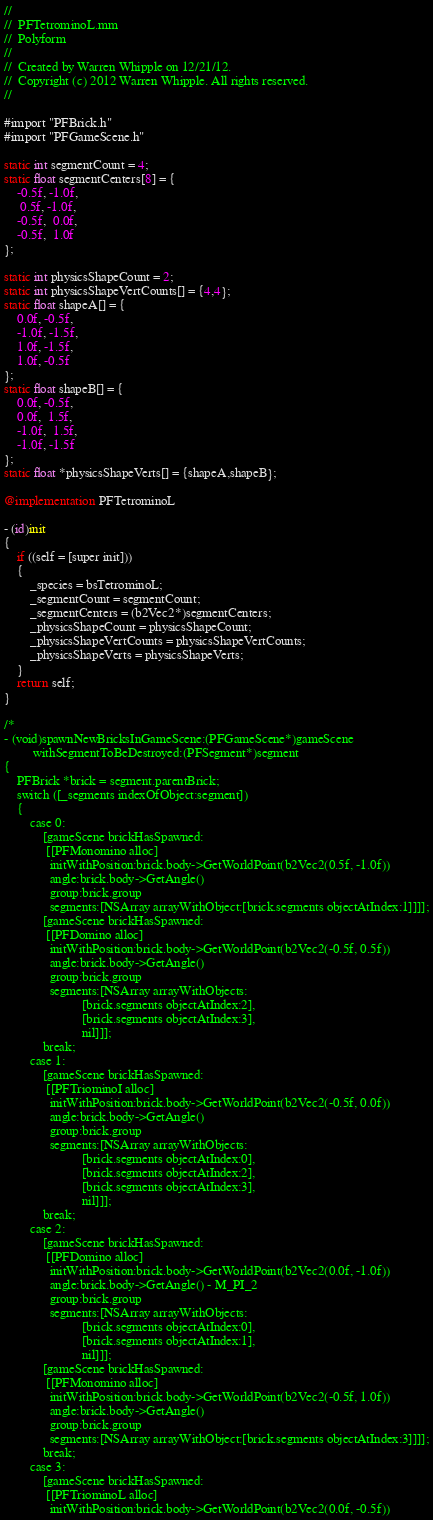<code> <loc_0><loc_0><loc_500><loc_500><_ObjectiveC_>//
//  PFTetrominoL.mm
//  Polyform
//
//  Created by Warren Whipple on 12/21/12.
//  Copyright (c) 2012 Warren Whipple. All rights reserved.
//

#import "PFBrick.h"
#import "PFGameScene.h"

static int segmentCount = 4;
static float segmentCenters[8] = {
    -0.5f, -1.0f,
     0.5f, -1.0f,
    -0.5f,  0.0f,
    -0.5f,  1.0f
};

static int physicsShapeCount = 2;
static int physicsShapeVertCounts[] = {4,4};
static float shapeA[] = {
    0.0f, -0.5f,
    -1.0f, -1.5f,
    1.0f, -1.5f,
    1.0f, -0.5f
};
static float shapeB[] = {
    0.0f, -0.5f,
    0.0f,  1.5f,
    -1.0f,  1.5f,
    -1.0f, -1.5f
};
static float *physicsShapeVerts[] = {shapeA,shapeB};

@implementation PFTetrominoL

- (id)init
{
    if ((self = [super init]))
    {
        _species = bsTetrominoL;
        _segmentCount = segmentCount;
        _segmentCenters = (b2Vec2*)segmentCenters;
        _physicsShapeCount = physicsShapeCount;
        _physicsShapeVertCounts = physicsShapeVertCounts;
        _physicsShapeVerts = physicsShapeVerts;
    }
    return self;
}

/*
- (void)spawnNewBricksInGameScene:(PFGameScene*)gameScene
         withSegmentToBeDestroyed:(PFSegment*)segment
{
    PFBrick *brick = segment.parentBrick;
    switch ([_segments indexOfObject:segment])
    {
        case 0:
            [gameScene brickHasSpawned:
             [[PFMonomino alloc]
              initWithPosition:brick.body->GetWorldPoint(b2Vec2(0.5f, -1.0f))
              angle:brick.body->GetAngle()
              group:brick.group
              segments:[NSArray arrayWithObject:[brick.segments objectAtIndex:1]]]];
            [gameScene brickHasSpawned:
             [[PFDomino alloc]
              initWithPosition:brick.body->GetWorldPoint(b2Vec2(-0.5f, 0.5f))
              angle:brick.body->GetAngle()
              group:brick.group
              segments:[NSArray arrayWithObjects:
                        [brick.segments objectAtIndex:2],
                        [brick.segments objectAtIndex:3],
                        nil]]];
            break;
        case 1:
            [gameScene brickHasSpawned:
             [[PFTriominoI alloc]
              initWithPosition:brick.body->GetWorldPoint(b2Vec2(-0.5f, 0.0f))
              angle:brick.body->GetAngle()
              group:brick.group
              segments:[NSArray arrayWithObjects:
                        [brick.segments objectAtIndex:0],
                        [brick.segments objectAtIndex:2],
                        [brick.segments objectAtIndex:3],
                        nil]]];
            break;
        case 2:
            [gameScene brickHasSpawned:
             [[PFDomino alloc]
              initWithPosition:brick.body->GetWorldPoint(b2Vec2(0.0f, -1.0f))
              angle:brick.body->GetAngle() - M_PI_2
              group:brick.group
              segments:[NSArray arrayWithObjects:
                        [brick.segments objectAtIndex:0],
                        [brick.segments objectAtIndex:1],
                        nil]]];
            [gameScene brickHasSpawned:
             [[PFMonomino alloc]
              initWithPosition:brick.body->GetWorldPoint(b2Vec2(-0.5f, 1.0f))
              angle:brick.body->GetAngle()
              group:brick.group
              segments:[NSArray arrayWithObject:[brick.segments objectAtIndex:3]]]];
            break;
        case 3:
            [gameScene brickHasSpawned:
             [[PFTriominoL alloc]
              initWithPosition:brick.body->GetWorldPoint(b2Vec2(0.0f, -0.5f))</code> 